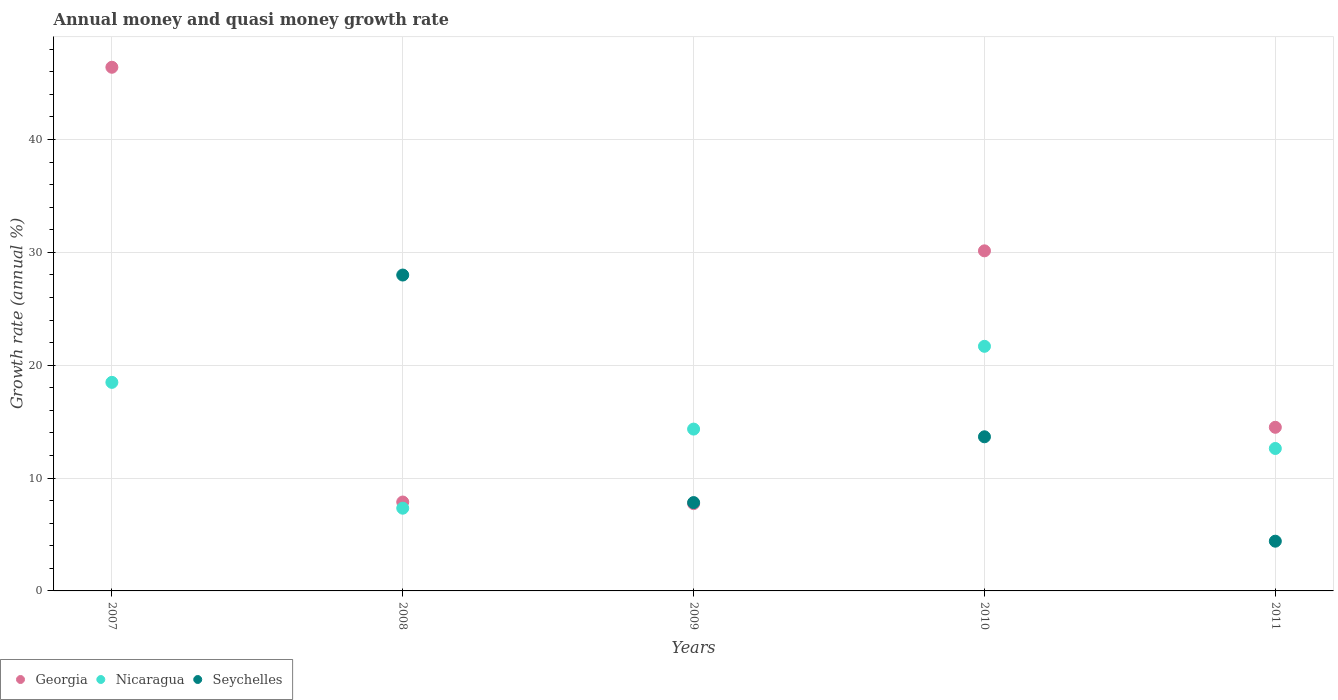How many different coloured dotlines are there?
Give a very brief answer. 3. Is the number of dotlines equal to the number of legend labels?
Ensure brevity in your answer.  No. What is the growth rate in Georgia in 2010?
Make the answer very short. 30.13. Across all years, what is the maximum growth rate in Nicaragua?
Your response must be concise. 21.67. In which year was the growth rate in Georgia maximum?
Offer a terse response. 2007. What is the total growth rate in Georgia in the graph?
Offer a terse response. 106.64. What is the difference between the growth rate in Nicaragua in 2007 and that in 2011?
Keep it short and to the point. 5.86. What is the difference between the growth rate in Seychelles in 2011 and the growth rate in Nicaragua in 2010?
Offer a very short reply. -17.27. What is the average growth rate in Georgia per year?
Give a very brief answer. 21.33. In the year 2008, what is the difference between the growth rate in Georgia and growth rate in Seychelles?
Your answer should be compact. -20.11. What is the ratio of the growth rate in Nicaragua in 2007 to that in 2010?
Provide a short and direct response. 0.85. What is the difference between the highest and the second highest growth rate in Georgia?
Your response must be concise. 16.27. What is the difference between the highest and the lowest growth rate in Georgia?
Provide a short and direct response. 38.67. In how many years, is the growth rate in Nicaragua greater than the average growth rate in Nicaragua taken over all years?
Make the answer very short. 2. Does the growth rate in Seychelles monotonically increase over the years?
Keep it short and to the point. No. Is the growth rate in Seychelles strictly greater than the growth rate in Nicaragua over the years?
Offer a very short reply. No. Does the graph contain any zero values?
Your answer should be very brief. Yes. Does the graph contain grids?
Give a very brief answer. Yes. How many legend labels are there?
Offer a very short reply. 3. How are the legend labels stacked?
Provide a short and direct response. Horizontal. What is the title of the graph?
Provide a short and direct response. Annual money and quasi money growth rate. What is the label or title of the Y-axis?
Your answer should be very brief. Growth rate (annual %). What is the Growth rate (annual %) in Georgia in 2007?
Provide a short and direct response. 46.4. What is the Growth rate (annual %) of Nicaragua in 2007?
Make the answer very short. 18.48. What is the Growth rate (annual %) of Georgia in 2008?
Keep it short and to the point. 7.88. What is the Growth rate (annual %) in Nicaragua in 2008?
Give a very brief answer. 7.33. What is the Growth rate (annual %) in Seychelles in 2008?
Ensure brevity in your answer.  27.99. What is the Growth rate (annual %) of Georgia in 2009?
Ensure brevity in your answer.  7.73. What is the Growth rate (annual %) of Nicaragua in 2009?
Your answer should be compact. 14.34. What is the Growth rate (annual %) of Seychelles in 2009?
Make the answer very short. 7.83. What is the Growth rate (annual %) in Georgia in 2010?
Provide a short and direct response. 30.13. What is the Growth rate (annual %) in Nicaragua in 2010?
Provide a succinct answer. 21.67. What is the Growth rate (annual %) of Seychelles in 2010?
Offer a terse response. 13.66. What is the Growth rate (annual %) of Georgia in 2011?
Provide a succinct answer. 14.5. What is the Growth rate (annual %) of Nicaragua in 2011?
Make the answer very short. 12.62. What is the Growth rate (annual %) in Seychelles in 2011?
Ensure brevity in your answer.  4.41. Across all years, what is the maximum Growth rate (annual %) of Georgia?
Make the answer very short. 46.4. Across all years, what is the maximum Growth rate (annual %) in Nicaragua?
Ensure brevity in your answer.  21.67. Across all years, what is the maximum Growth rate (annual %) in Seychelles?
Offer a very short reply. 27.99. Across all years, what is the minimum Growth rate (annual %) in Georgia?
Keep it short and to the point. 7.73. Across all years, what is the minimum Growth rate (annual %) of Nicaragua?
Make the answer very short. 7.33. Across all years, what is the minimum Growth rate (annual %) in Seychelles?
Give a very brief answer. 0. What is the total Growth rate (annual %) in Georgia in the graph?
Offer a terse response. 106.64. What is the total Growth rate (annual %) of Nicaragua in the graph?
Provide a succinct answer. 74.44. What is the total Growth rate (annual %) in Seychelles in the graph?
Offer a terse response. 53.88. What is the difference between the Growth rate (annual %) in Georgia in 2007 and that in 2008?
Give a very brief answer. 38.52. What is the difference between the Growth rate (annual %) of Nicaragua in 2007 and that in 2008?
Your answer should be very brief. 11.15. What is the difference between the Growth rate (annual %) in Georgia in 2007 and that in 2009?
Provide a short and direct response. 38.67. What is the difference between the Growth rate (annual %) in Nicaragua in 2007 and that in 2009?
Provide a succinct answer. 4.14. What is the difference between the Growth rate (annual %) in Georgia in 2007 and that in 2010?
Your answer should be compact. 16.27. What is the difference between the Growth rate (annual %) in Nicaragua in 2007 and that in 2010?
Your response must be concise. -3.19. What is the difference between the Growth rate (annual %) in Georgia in 2007 and that in 2011?
Your answer should be very brief. 31.9. What is the difference between the Growth rate (annual %) of Nicaragua in 2007 and that in 2011?
Offer a very short reply. 5.86. What is the difference between the Growth rate (annual %) of Georgia in 2008 and that in 2009?
Keep it short and to the point. 0.14. What is the difference between the Growth rate (annual %) of Nicaragua in 2008 and that in 2009?
Offer a very short reply. -7.01. What is the difference between the Growth rate (annual %) of Seychelles in 2008 and that in 2009?
Provide a short and direct response. 20.16. What is the difference between the Growth rate (annual %) in Georgia in 2008 and that in 2010?
Give a very brief answer. -22.26. What is the difference between the Growth rate (annual %) in Nicaragua in 2008 and that in 2010?
Offer a very short reply. -14.34. What is the difference between the Growth rate (annual %) of Seychelles in 2008 and that in 2010?
Keep it short and to the point. 14.33. What is the difference between the Growth rate (annual %) in Georgia in 2008 and that in 2011?
Keep it short and to the point. -6.62. What is the difference between the Growth rate (annual %) in Nicaragua in 2008 and that in 2011?
Provide a short and direct response. -5.29. What is the difference between the Growth rate (annual %) of Seychelles in 2008 and that in 2011?
Keep it short and to the point. 23.58. What is the difference between the Growth rate (annual %) of Georgia in 2009 and that in 2010?
Offer a terse response. -22.4. What is the difference between the Growth rate (annual %) in Nicaragua in 2009 and that in 2010?
Your answer should be very brief. -7.33. What is the difference between the Growth rate (annual %) of Seychelles in 2009 and that in 2010?
Keep it short and to the point. -5.83. What is the difference between the Growth rate (annual %) in Georgia in 2009 and that in 2011?
Your response must be concise. -6.77. What is the difference between the Growth rate (annual %) of Nicaragua in 2009 and that in 2011?
Offer a very short reply. 1.72. What is the difference between the Growth rate (annual %) of Seychelles in 2009 and that in 2011?
Your answer should be very brief. 3.42. What is the difference between the Growth rate (annual %) of Georgia in 2010 and that in 2011?
Keep it short and to the point. 15.63. What is the difference between the Growth rate (annual %) of Nicaragua in 2010 and that in 2011?
Offer a very short reply. 9.05. What is the difference between the Growth rate (annual %) of Seychelles in 2010 and that in 2011?
Your answer should be very brief. 9.25. What is the difference between the Growth rate (annual %) of Georgia in 2007 and the Growth rate (annual %) of Nicaragua in 2008?
Provide a succinct answer. 39.07. What is the difference between the Growth rate (annual %) of Georgia in 2007 and the Growth rate (annual %) of Seychelles in 2008?
Provide a succinct answer. 18.41. What is the difference between the Growth rate (annual %) of Nicaragua in 2007 and the Growth rate (annual %) of Seychelles in 2008?
Your response must be concise. -9.51. What is the difference between the Growth rate (annual %) of Georgia in 2007 and the Growth rate (annual %) of Nicaragua in 2009?
Make the answer very short. 32.06. What is the difference between the Growth rate (annual %) of Georgia in 2007 and the Growth rate (annual %) of Seychelles in 2009?
Offer a terse response. 38.57. What is the difference between the Growth rate (annual %) in Nicaragua in 2007 and the Growth rate (annual %) in Seychelles in 2009?
Offer a very short reply. 10.65. What is the difference between the Growth rate (annual %) of Georgia in 2007 and the Growth rate (annual %) of Nicaragua in 2010?
Offer a terse response. 24.73. What is the difference between the Growth rate (annual %) in Georgia in 2007 and the Growth rate (annual %) in Seychelles in 2010?
Provide a succinct answer. 32.74. What is the difference between the Growth rate (annual %) of Nicaragua in 2007 and the Growth rate (annual %) of Seychelles in 2010?
Make the answer very short. 4.82. What is the difference between the Growth rate (annual %) in Georgia in 2007 and the Growth rate (annual %) in Nicaragua in 2011?
Offer a terse response. 33.78. What is the difference between the Growth rate (annual %) of Georgia in 2007 and the Growth rate (annual %) of Seychelles in 2011?
Offer a terse response. 41.99. What is the difference between the Growth rate (annual %) of Nicaragua in 2007 and the Growth rate (annual %) of Seychelles in 2011?
Make the answer very short. 14.07. What is the difference between the Growth rate (annual %) of Georgia in 2008 and the Growth rate (annual %) of Nicaragua in 2009?
Your answer should be compact. -6.46. What is the difference between the Growth rate (annual %) of Georgia in 2008 and the Growth rate (annual %) of Seychelles in 2009?
Provide a succinct answer. 0.05. What is the difference between the Growth rate (annual %) in Nicaragua in 2008 and the Growth rate (annual %) in Seychelles in 2009?
Give a very brief answer. -0.5. What is the difference between the Growth rate (annual %) of Georgia in 2008 and the Growth rate (annual %) of Nicaragua in 2010?
Make the answer very short. -13.8. What is the difference between the Growth rate (annual %) in Georgia in 2008 and the Growth rate (annual %) in Seychelles in 2010?
Give a very brief answer. -5.78. What is the difference between the Growth rate (annual %) of Nicaragua in 2008 and the Growth rate (annual %) of Seychelles in 2010?
Your response must be concise. -6.33. What is the difference between the Growth rate (annual %) of Georgia in 2008 and the Growth rate (annual %) of Nicaragua in 2011?
Offer a terse response. -4.75. What is the difference between the Growth rate (annual %) of Georgia in 2008 and the Growth rate (annual %) of Seychelles in 2011?
Provide a short and direct response. 3.47. What is the difference between the Growth rate (annual %) of Nicaragua in 2008 and the Growth rate (annual %) of Seychelles in 2011?
Your answer should be compact. 2.92. What is the difference between the Growth rate (annual %) of Georgia in 2009 and the Growth rate (annual %) of Nicaragua in 2010?
Your answer should be compact. -13.94. What is the difference between the Growth rate (annual %) in Georgia in 2009 and the Growth rate (annual %) in Seychelles in 2010?
Make the answer very short. -5.92. What is the difference between the Growth rate (annual %) of Nicaragua in 2009 and the Growth rate (annual %) of Seychelles in 2010?
Provide a short and direct response. 0.68. What is the difference between the Growth rate (annual %) of Georgia in 2009 and the Growth rate (annual %) of Nicaragua in 2011?
Provide a short and direct response. -4.89. What is the difference between the Growth rate (annual %) of Georgia in 2009 and the Growth rate (annual %) of Seychelles in 2011?
Offer a very short reply. 3.33. What is the difference between the Growth rate (annual %) in Nicaragua in 2009 and the Growth rate (annual %) in Seychelles in 2011?
Your answer should be compact. 9.93. What is the difference between the Growth rate (annual %) of Georgia in 2010 and the Growth rate (annual %) of Nicaragua in 2011?
Make the answer very short. 17.51. What is the difference between the Growth rate (annual %) in Georgia in 2010 and the Growth rate (annual %) in Seychelles in 2011?
Keep it short and to the point. 25.73. What is the difference between the Growth rate (annual %) of Nicaragua in 2010 and the Growth rate (annual %) of Seychelles in 2011?
Offer a very short reply. 17.27. What is the average Growth rate (annual %) in Georgia per year?
Provide a succinct answer. 21.33. What is the average Growth rate (annual %) of Nicaragua per year?
Provide a succinct answer. 14.89. What is the average Growth rate (annual %) of Seychelles per year?
Give a very brief answer. 10.78. In the year 2007, what is the difference between the Growth rate (annual %) of Georgia and Growth rate (annual %) of Nicaragua?
Give a very brief answer. 27.92. In the year 2008, what is the difference between the Growth rate (annual %) in Georgia and Growth rate (annual %) in Nicaragua?
Your answer should be compact. 0.55. In the year 2008, what is the difference between the Growth rate (annual %) of Georgia and Growth rate (annual %) of Seychelles?
Your answer should be very brief. -20.11. In the year 2008, what is the difference between the Growth rate (annual %) of Nicaragua and Growth rate (annual %) of Seychelles?
Your answer should be very brief. -20.66. In the year 2009, what is the difference between the Growth rate (annual %) of Georgia and Growth rate (annual %) of Nicaragua?
Provide a succinct answer. -6.61. In the year 2009, what is the difference between the Growth rate (annual %) of Georgia and Growth rate (annual %) of Seychelles?
Make the answer very short. -0.1. In the year 2009, what is the difference between the Growth rate (annual %) in Nicaragua and Growth rate (annual %) in Seychelles?
Provide a succinct answer. 6.51. In the year 2010, what is the difference between the Growth rate (annual %) of Georgia and Growth rate (annual %) of Nicaragua?
Make the answer very short. 8.46. In the year 2010, what is the difference between the Growth rate (annual %) in Georgia and Growth rate (annual %) in Seychelles?
Offer a very short reply. 16.48. In the year 2010, what is the difference between the Growth rate (annual %) in Nicaragua and Growth rate (annual %) in Seychelles?
Your answer should be compact. 8.02. In the year 2011, what is the difference between the Growth rate (annual %) in Georgia and Growth rate (annual %) in Nicaragua?
Provide a short and direct response. 1.88. In the year 2011, what is the difference between the Growth rate (annual %) of Georgia and Growth rate (annual %) of Seychelles?
Your response must be concise. 10.09. In the year 2011, what is the difference between the Growth rate (annual %) in Nicaragua and Growth rate (annual %) in Seychelles?
Keep it short and to the point. 8.21. What is the ratio of the Growth rate (annual %) of Georgia in 2007 to that in 2008?
Your response must be concise. 5.89. What is the ratio of the Growth rate (annual %) in Nicaragua in 2007 to that in 2008?
Your response must be concise. 2.52. What is the ratio of the Growth rate (annual %) in Georgia in 2007 to that in 2009?
Make the answer very short. 6. What is the ratio of the Growth rate (annual %) in Nicaragua in 2007 to that in 2009?
Offer a terse response. 1.29. What is the ratio of the Growth rate (annual %) of Georgia in 2007 to that in 2010?
Make the answer very short. 1.54. What is the ratio of the Growth rate (annual %) in Nicaragua in 2007 to that in 2010?
Offer a very short reply. 0.85. What is the ratio of the Growth rate (annual %) in Georgia in 2007 to that in 2011?
Give a very brief answer. 3.2. What is the ratio of the Growth rate (annual %) in Nicaragua in 2007 to that in 2011?
Make the answer very short. 1.46. What is the ratio of the Growth rate (annual %) of Georgia in 2008 to that in 2009?
Offer a terse response. 1.02. What is the ratio of the Growth rate (annual %) of Nicaragua in 2008 to that in 2009?
Keep it short and to the point. 0.51. What is the ratio of the Growth rate (annual %) in Seychelles in 2008 to that in 2009?
Your response must be concise. 3.58. What is the ratio of the Growth rate (annual %) in Georgia in 2008 to that in 2010?
Ensure brevity in your answer.  0.26. What is the ratio of the Growth rate (annual %) of Nicaragua in 2008 to that in 2010?
Offer a terse response. 0.34. What is the ratio of the Growth rate (annual %) in Seychelles in 2008 to that in 2010?
Give a very brief answer. 2.05. What is the ratio of the Growth rate (annual %) of Georgia in 2008 to that in 2011?
Offer a terse response. 0.54. What is the ratio of the Growth rate (annual %) of Nicaragua in 2008 to that in 2011?
Offer a very short reply. 0.58. What is the ratio of the Growth rate (annual %) in Seychelles in 2008 to that in 2011?
Your answer should be compact. 6.35. What is the ratio of the Growth rate (annual %) in Georgia in 2009 to that in 2010?
Your response must be concise. 0.26. What is the ratio of the Growth rate (annual %) in Nicaragua in 2009 to that in 2010?
Make the answer very short. 0.66. What is the ratio of the Growth rate (annual %) in Seychelles in 2009 to that in 2010?
Give a very brief answer. 0.57. What is the ratio of the Growth rate (annual %) in Georgia in 2009 to that in 2011?
Give a very brief answer. 0.53. What is the ratio of the Growth rate (annual %) in Nicaragua in 2009 to that in 2011?
Provide a short and direct response. 1.14. What is the ratio of the Growth rate (annual %) of Seychelles in 2009 to that in 2011?
Make the answer very short. 1.78. What is the ratio of the Growth rate (annual %) of Georgia in 2010 to that in 2011?
Your answer should be very brief. 2.08. What is the ratio of the Growth rate (annual %) in Nicaragua in 2010 to that in 2011?
Keep it short and to the point. 1.72. What is the ratio of the Growth rate (annual %) in Seychelles in 2010 to that in 2011?
Make the answer very short. 3.1. What is the difference between the highest and the second highest Growth rate (annual %) in Georgia?
Offer a terse response. 16.27. What is the difference between the highest and the second highest Growth rate (annual %) in Nicaragua?
Provide a succinct answer. 3.19. What is the difference between the highest and the second highest Growth rate (annual %) in Seychelles?
Ensure brevity in your answer.  14.33. What is the difference between the highest and the lowest Growth rate (annual %) in Georgia?
Offer a terse response. 38.67. What is the difference between the highest and the lowest Growth rate (annual %) of Nicaragua?
Offer a terse response. 14.34. What is the difference between the highest and the lowest Growth rate (annual %) in Seychelles?
Offer a terse response. 27.99. 